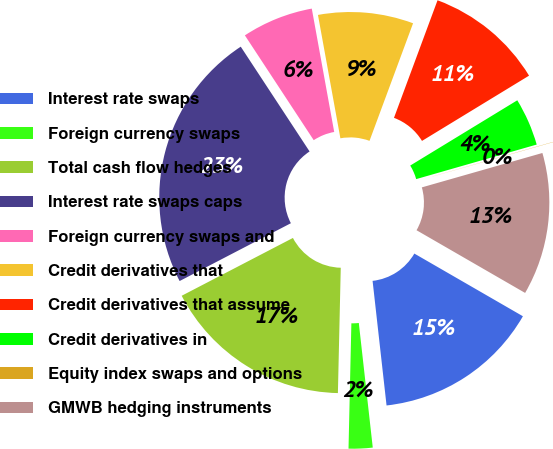Convert chart. <chart><loc_0><loc_0><loc_500><loc_500><pie_chart><fcel>Interest rate swaps<fcel>Foreign currency swaps<fcel>Total cash flow hedges<fcel>Interest rate swaps caps<fcel>Foreign currency swaps and<fcel>Credit derivatives that<fcel>Credit derivatives that assume<fcel>Credit derivatives in<fcel>Equity index swaps and options<fcel>GMWB hedging instruments<nl><fcel>14.89%<fcel>2.14%<fcel>17.01%<fcel>23.38%<fcel>6.39%<fcel>8.51%<fcel>10.64%<fcel>4.27%<fcel>0.02%<fcel>12.76%<nl></chart> 